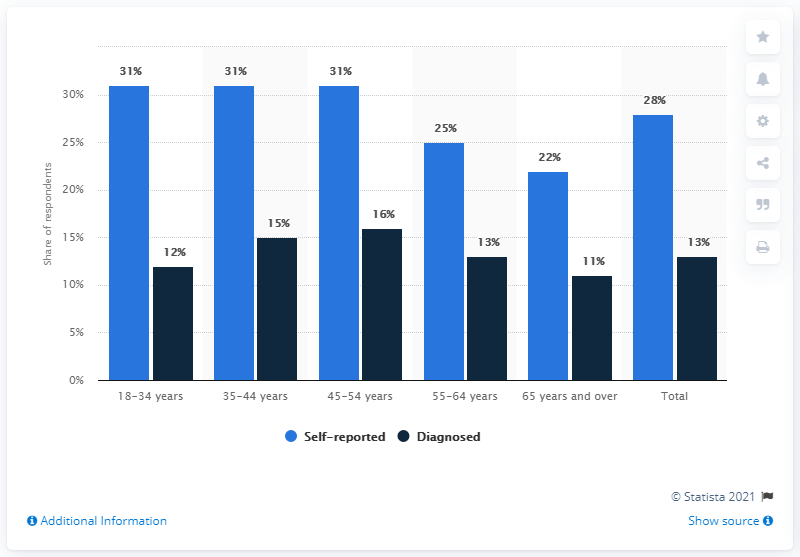Give some essential details in this illustration. The age group of 65 years and over reported the least difference between self-reported and diagnosed cases. What is the mode of the navy blue bars?" is a question that seeks to determine the value that appears most frequently in a group of data. 16 is one possible answer to this question, as it is the value that appears most frequently in the group of navy blue bars. 